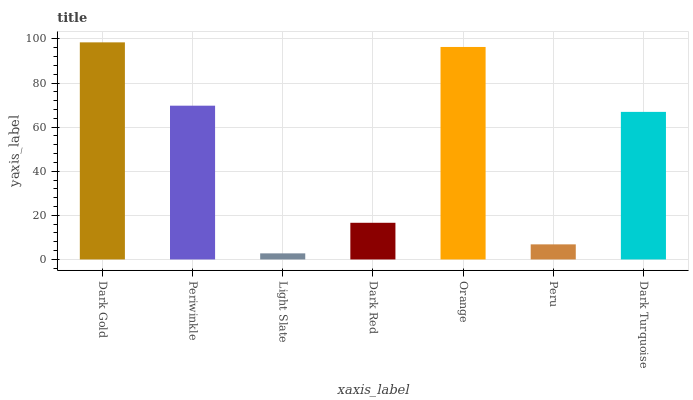Is Periwinkle the minimum?
Answer yes or no. No. Is Periwinkle the maximum?
Answer yes or no. No. Is Dark Gold greater than Periwinkle?
Answer yes or no. Yes. Is Periwinkle less than Dark Gold?
Answer yes or no. Yes. Is Periwinkle greater than Dark Gold?
Answer yes or no. No. Is Dark Gold less than Periwinkle?
Answer yes or no. No. Is Dark Turquoise the high median?
Answer yes or no. Yes. Is Dark Turquoise the low median?
Answer yes or no. Yes. Is Orange the high median?
Answer yes or no. No. Is Periwinkle the low median?
Answer yes or no. No. 